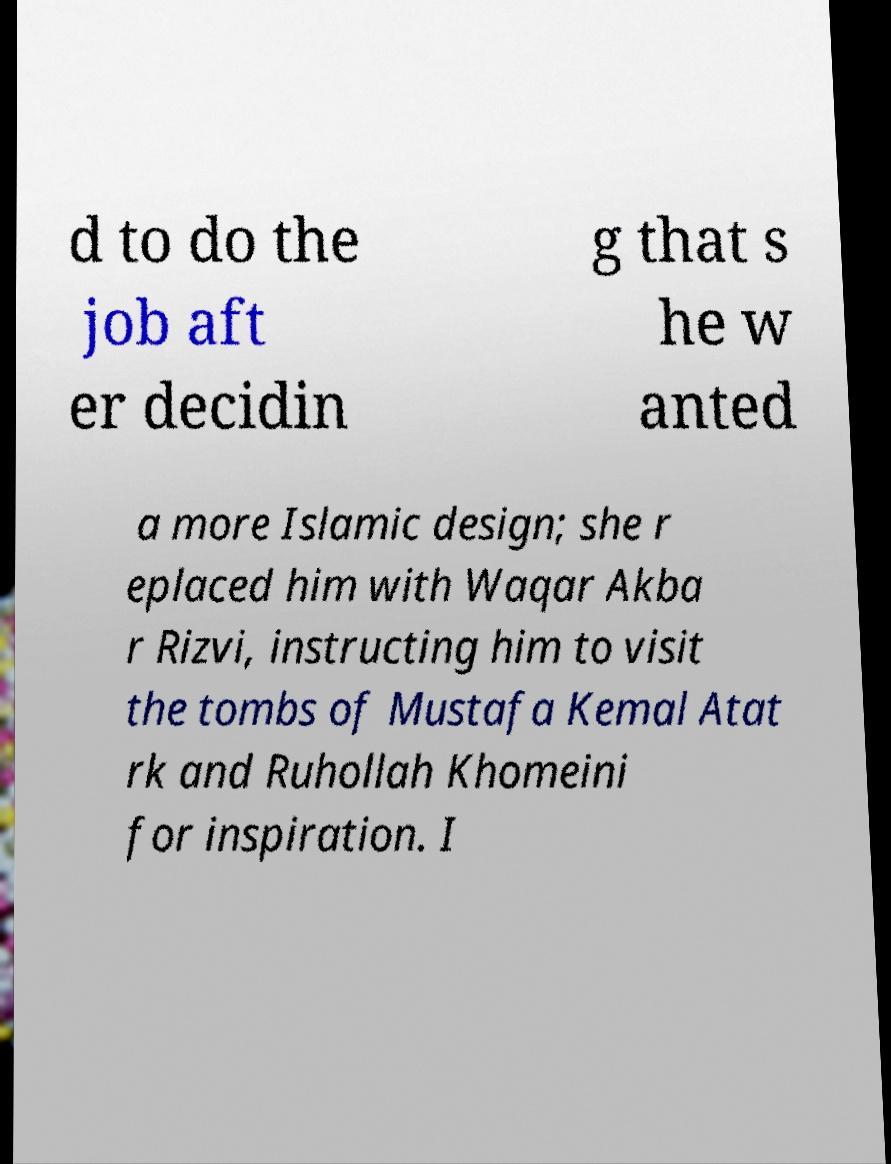Please identify and transcribe the text found in this image. d to do the job aft er decidin g that s he w anted a more Islamic design; she r eplaced him with Waqar Akba r Rizvi, instructing him to visit the tombs of Mustafa Kemal Atat rk and Ruhollah Khomeini for inspiration. I 